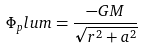Convert formula to latex. <formula><loc_0><loc_0><loc_500><loc_500>\Phi _ { p } l u m = \frac { - G M } { \sqrt { r ^ { 2 } + a ^ { 2 } } }</formula> 